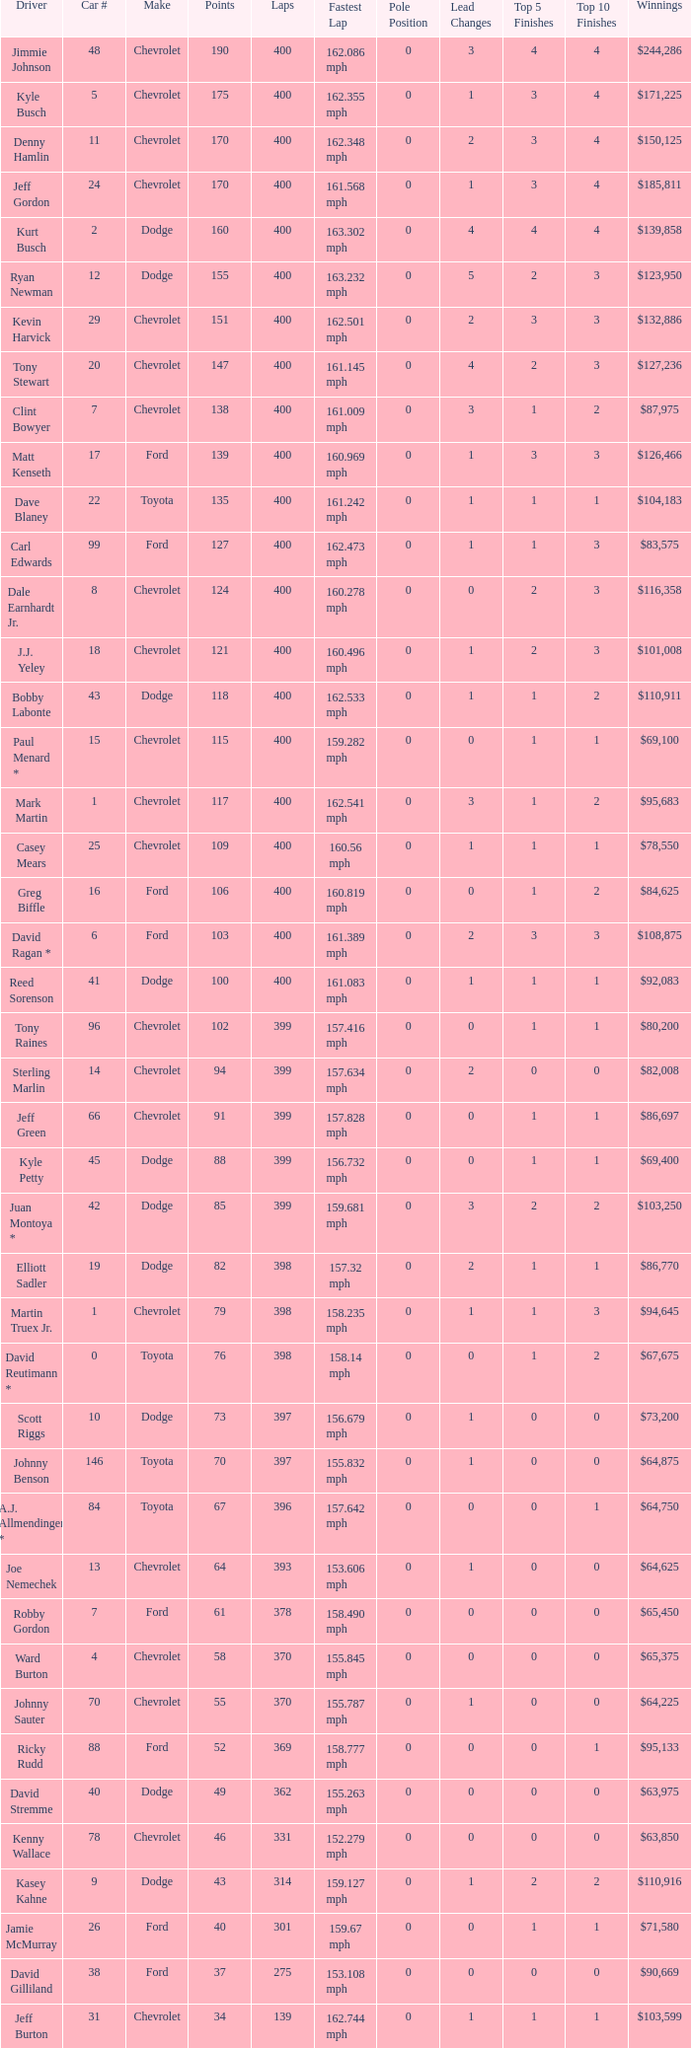What were the winnings for the Chevrolet with a number larger than 29 and scored 102 points? $80,200. 